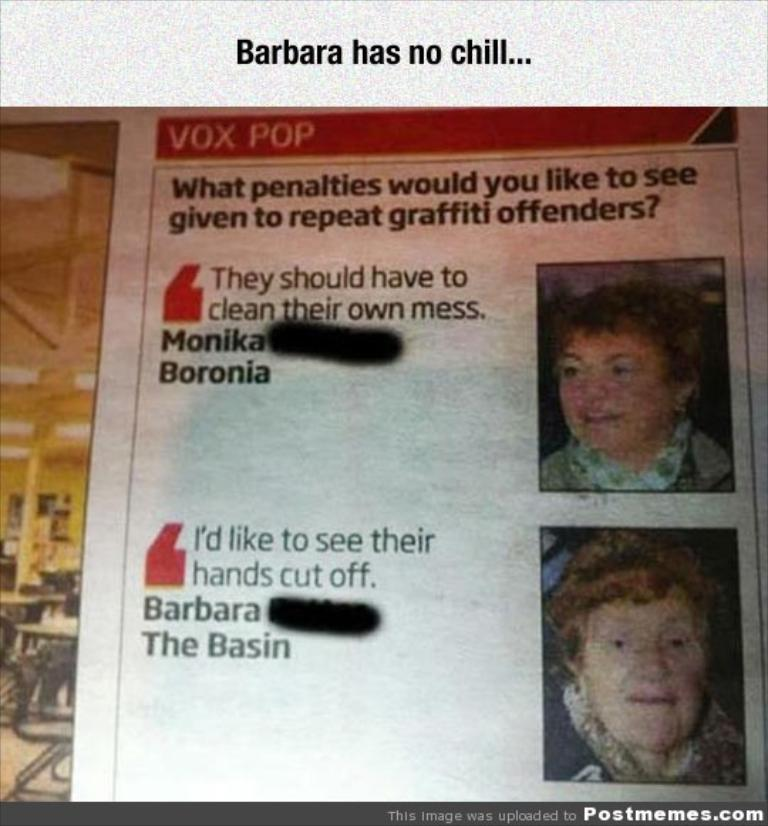What is the main object in the image? There is a magazine in the image. What type of content can be found in the magazine? The magazine contains information. Are there any specific images or features in the magazine? Yes, there are two women's images in the magazine. What type of juice is being served to the doctor in the image? There is no doctor or juice present in the image; it only features a magazine with two women's images. How many balloons are visible in the image? There are no balloons present in the image; it only features a magazine with two women's images. 